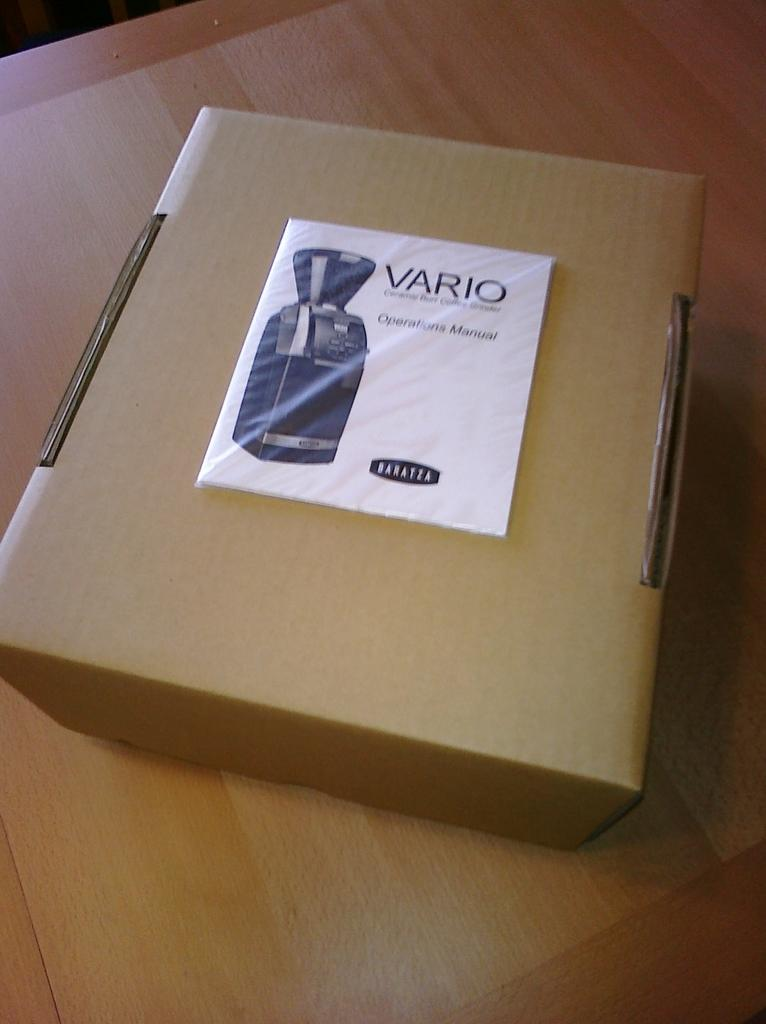<image>
Create a compact narrative representing the image presented. A Baratza brand coffee maker is packed inside of a cardboard box. 